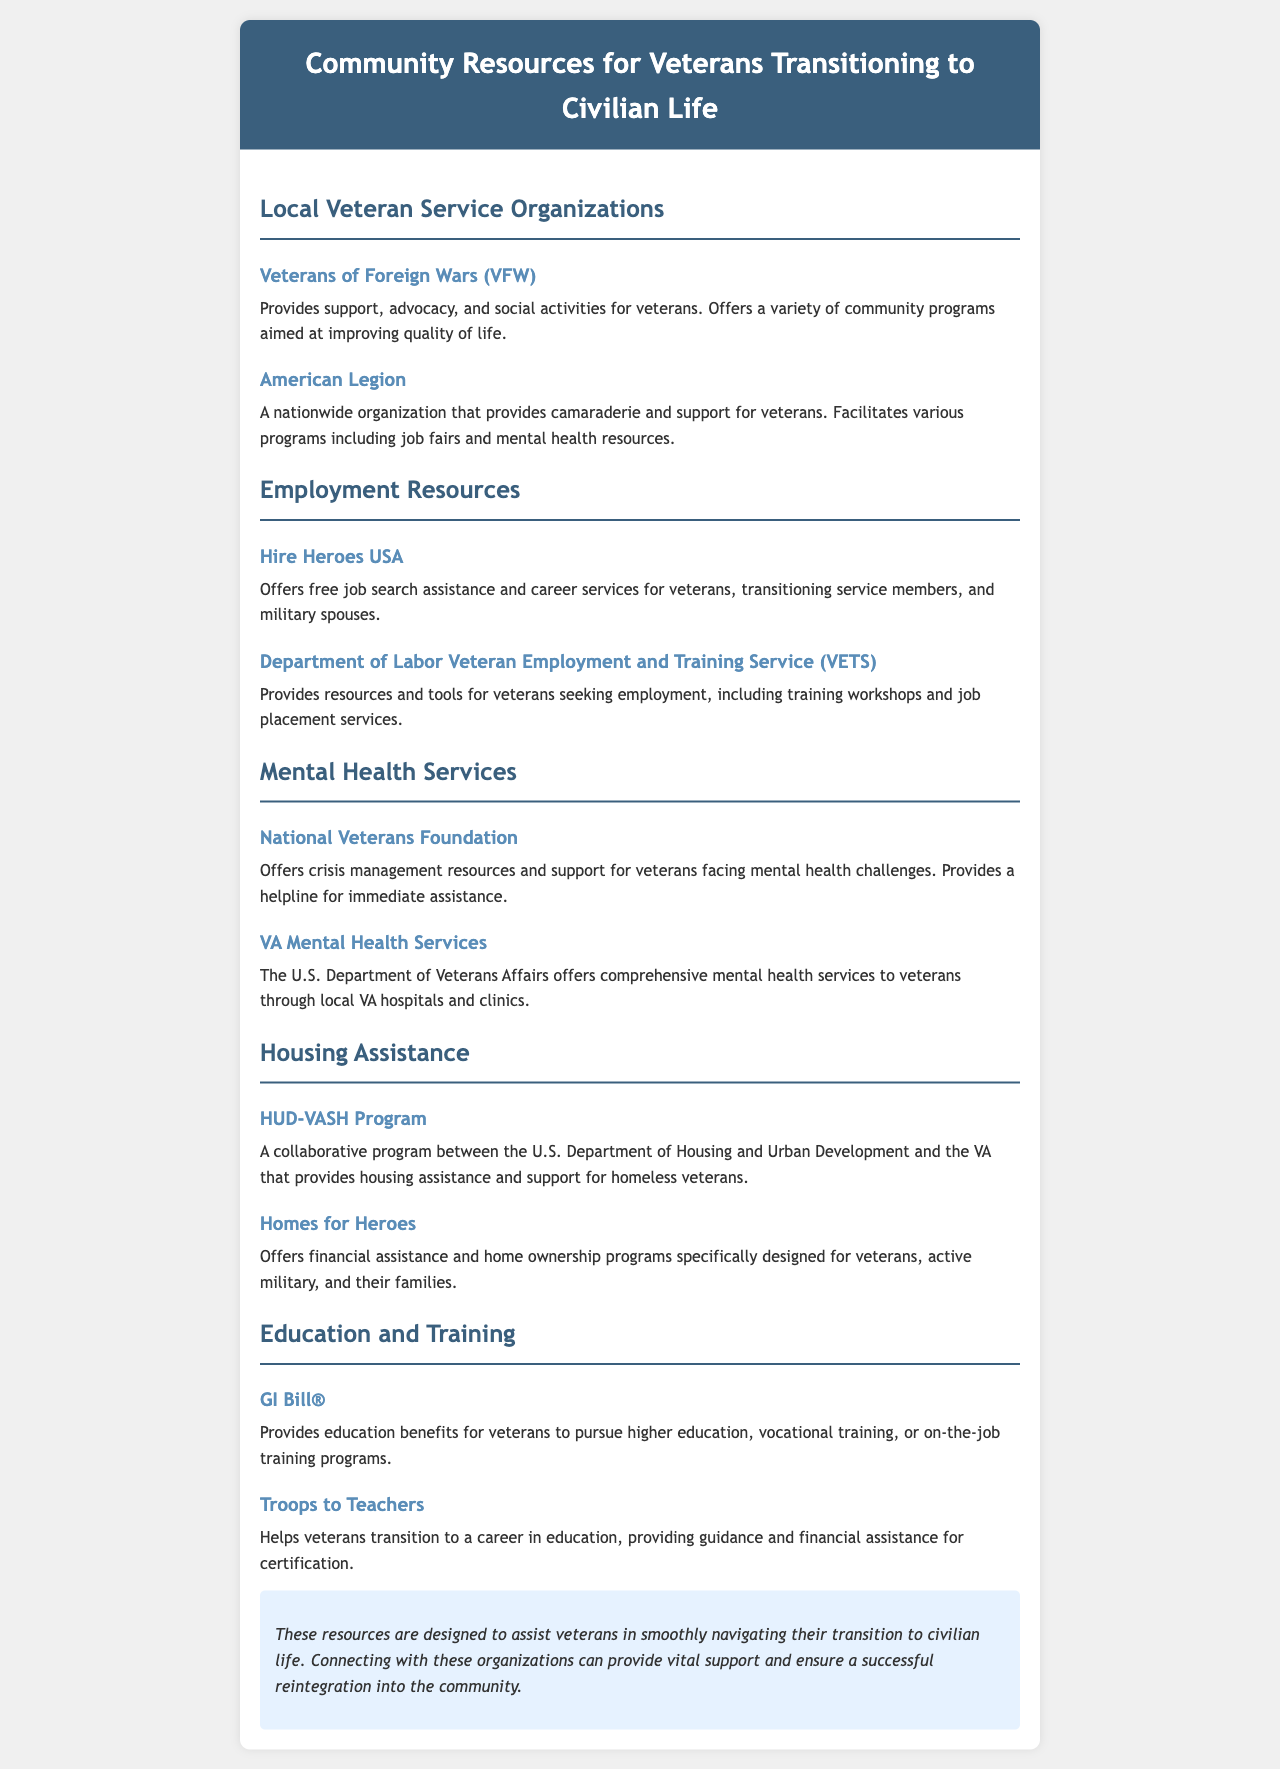What organization provides advocacy and social activities for veterans? The Veterans of Foreign Wars (VFW) is mentioned as providing support, advocacy, and social activities for veterans.
Answer: Veterans of Foreign Wars (VFW) Which program offers job search assistance and services for veterans? Hire Heroes USA is specifically highlighted as offering free job search assistance and career services.
Answer: Hire Heroes USA What does the GI Bill provide for veterans? The GI Bill provides education benefits for veterans to pursue higher education or vocational training.
Answer: Education benefits Which organization helps veterans transition to a career in education? The Troops to Teachers program is designed to assist veterans in transitioning to a career in education.
Answer: Troops to Teachers How many local veteran service organizations are mentioned in the brochure? There are three local veteran service organizations listed: VFW, American Legion, and National Veterans Foundation.
Answer: Three 